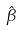Convert formula to latex. <formula><loc_0><loc_0><loc_500><loc_500>\hat { \beta }</formula> 